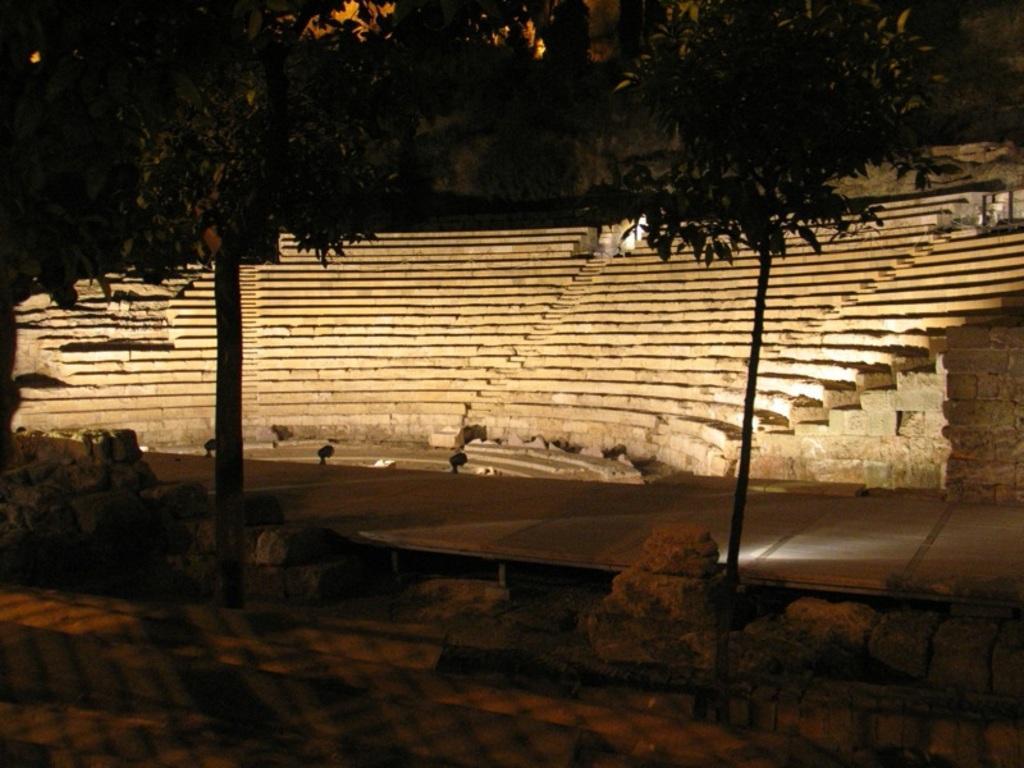Could you give a brief overview of what you see in this image? In this image I can see staircase and trees and the road. 